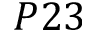<formula> <loc_0><loc_0><loc_500><loc_500>P 2 3</formula> 